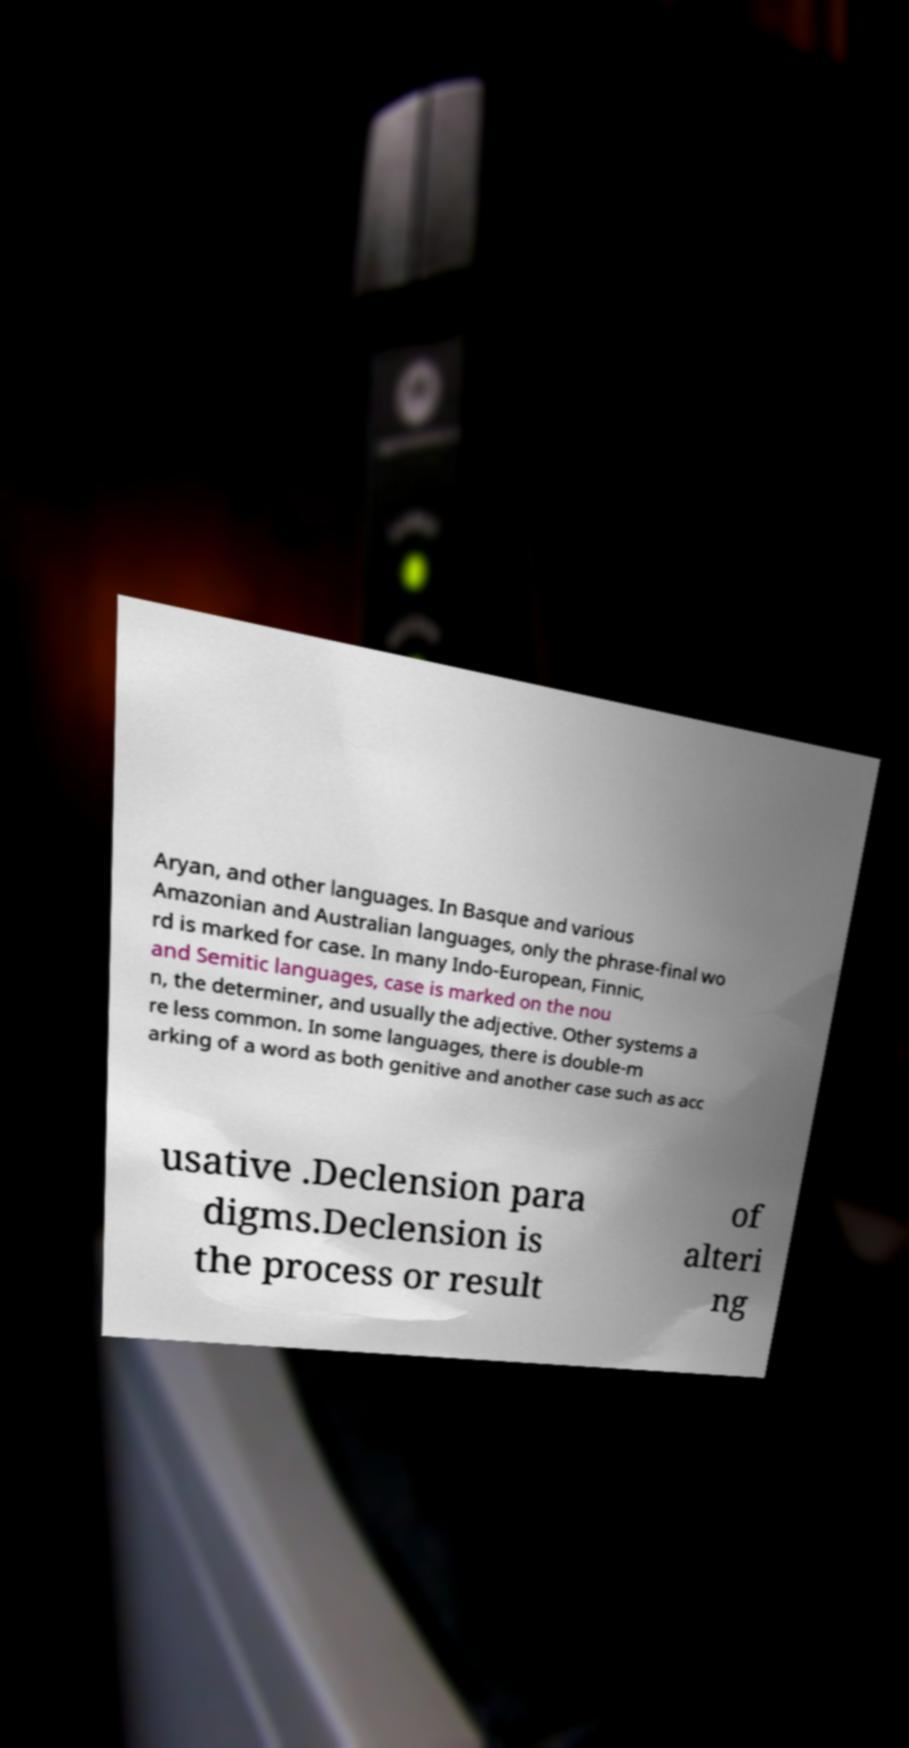Please identify and transcribe the text found in this image. Aryan, and other languages. In Basque and various Amazonian and Australian languages, only the phrase-final wo rd is marked for case. In many Indo-European, Finnic, and Semitic languages, case is marked on the nou n, the determiner, and usually the adjective. Other systems a re less common. In some languages, there is double-m arking of a word as both genitive and another case such as acc usative .Declension para digms.Declension is the process or result of alteri ng 